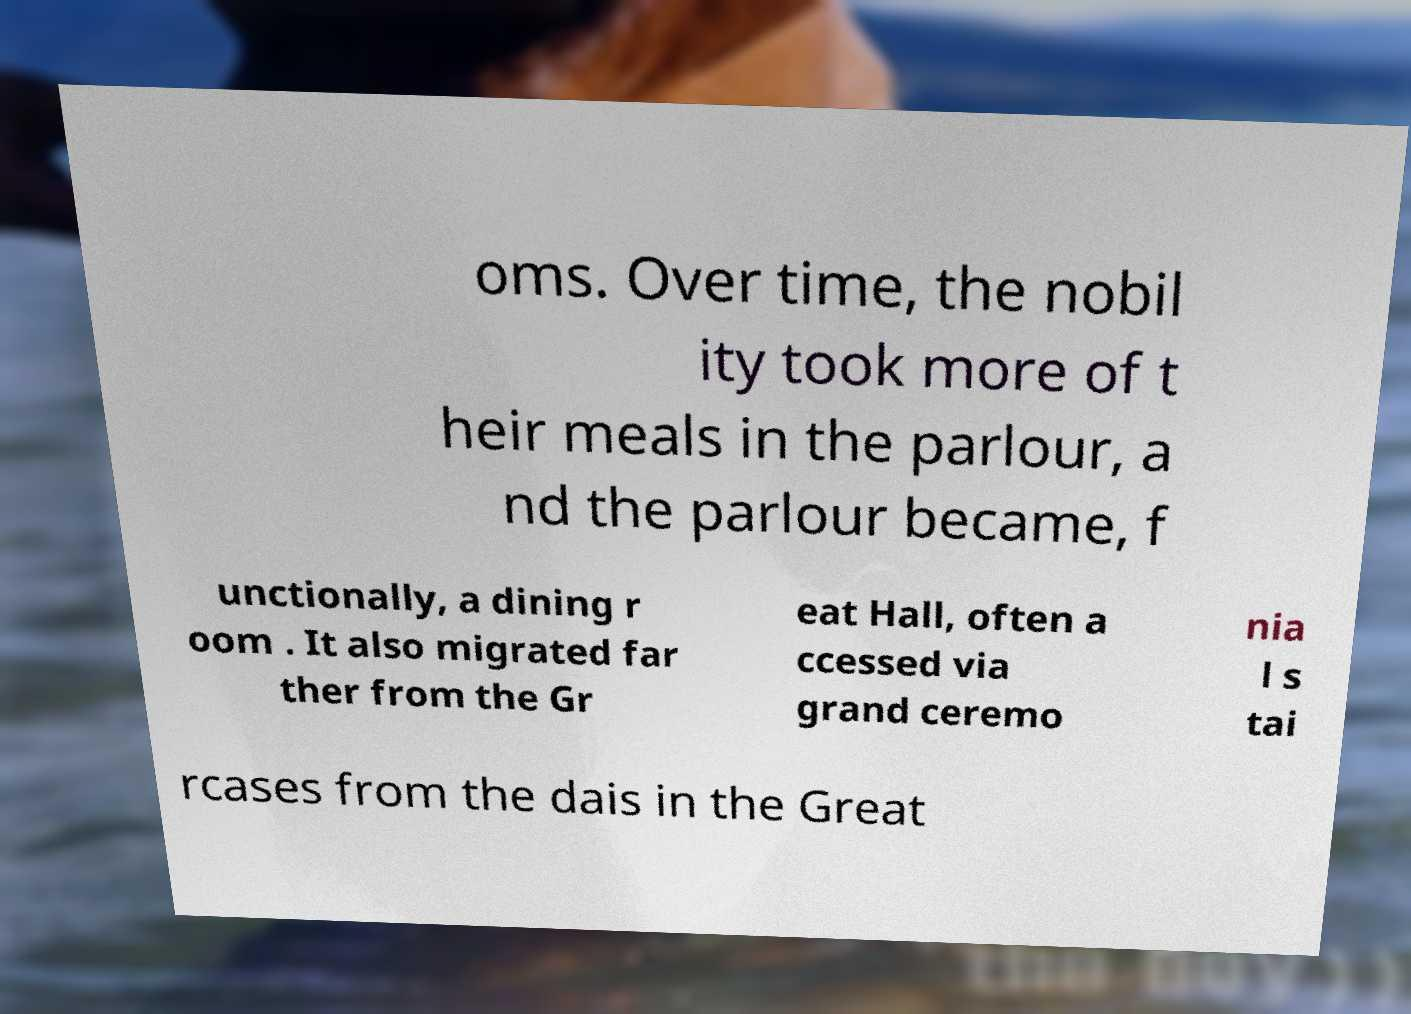Can you accurately transcribe the text from the provided image for me? oms. Over time, the nobil ity took more of t heir meals in the parlour, a nd the parlour became, f unctionally, a dining r oom . It also migrated far ther from the Gr eat Hall, often a ccessed via grand ceremo nia l s tai rcases from the dais in the Great 